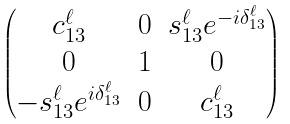Convert formula to latex. <formula><loc_0><loc_0><loc_500><loc_500>\begin{pmatrix} c _ { 1 3 } ^ { \ell } & 0 & s _ { 1 3 } ^ { \ell } e ^ { - i \delta ^ { \ell } _ { 1 3 } } \\ 0 & 1 & 0 \\ - s _ { 1 3 } ^ { \ell } e ^ { i \delta ^ { \ell } _ { 1 3 } } & 0 & c _ { 1 3 } ^ { \ell } \\ \end{pmatrix}</formula> 